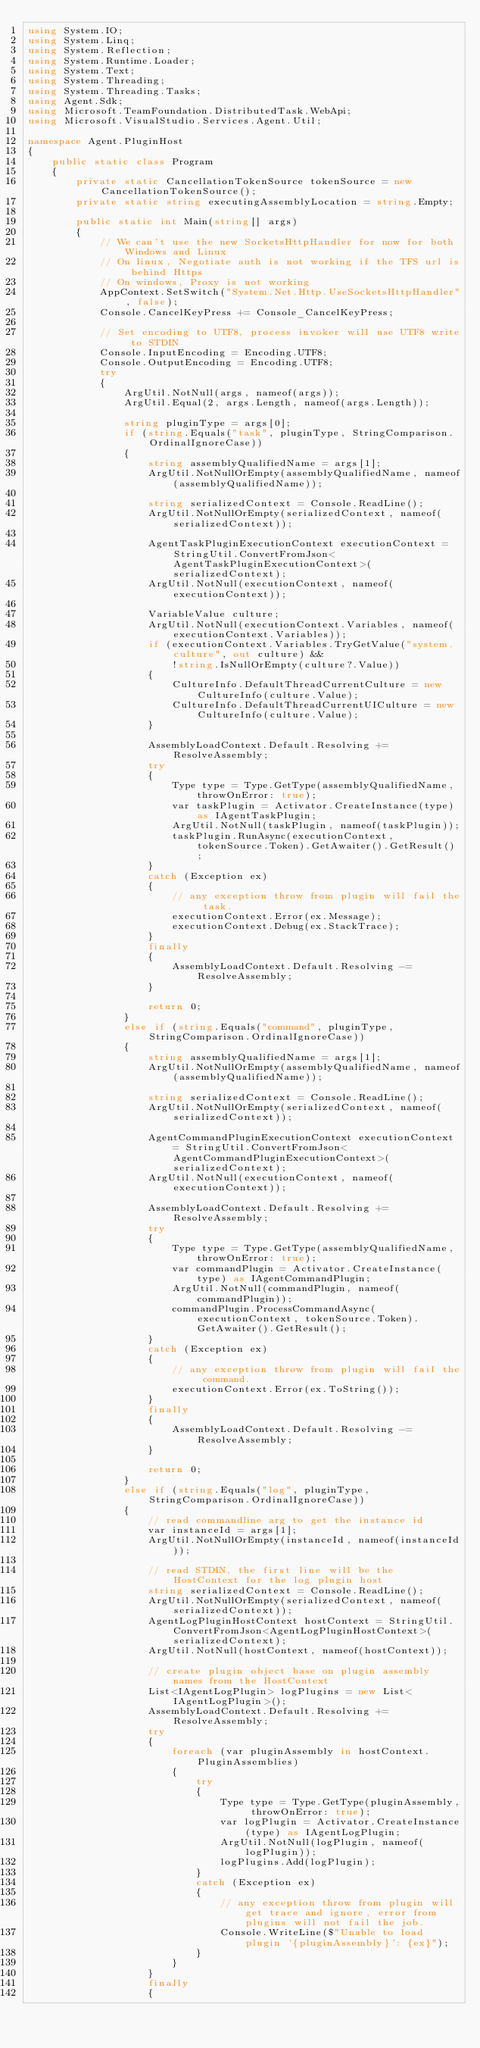<code> <loc_0><loc_0><loc_500><loc_500><_C#_>using System.IO;
using System.Linq;
using System.Reflection;
using System.Runtime.Loader;
using System.Text;
using System.Threading;
using System.Threading.Tasks;
using Agent.Sdk;
using Microsoft.TeamFoundation.DistributedTask.WebApi;
using Microsoft.VisualStudio.Services.Agent.Util;

namespace Agent.PluginHost
{
    public static class Program
    {
        private static CancellationTokenSource tokenSource = new CancellationTokenSource();
        private static string executingAssemblyLocation = string.Empty;

        public static int Main(string[] args)
        {
            // We can't use the new SocketsHttpHandler for now for both Windows and Linux
            // On linux, Negotiate auth is not working if the TFS url is behind Https
            // On windows, Proxy is not working
            AppContext.SetSwitch("System.Net.Http.UseSocketsHttpHandler", false);
            Console.CancelKeyPress += Console_CancelKeyPress;

            // Set encoding to UTF8, process invoker will use UTF8 write to STDIN
            Console.InputEncoding = Encoding.UTF8;
            Console.OutputEncoding = Encoding.UTF8;
            try
            {
                ArgUtil.NotNull(args, nameof(args));
                ArgUtil.Equal(2, args.Length, nameof(args.Length));

                string pluginType = args[0];
                if (string.Equals("task", pluginType, StringComparison.OrdinalIgnoreCase))
                {
                    string assemblyQualifiedName = args[1];
                    ArgUtil.NotNullOrEmpty(assemblyQualifiedName, nameof(assemblyQualifiedName));

                    string serializedContext = Console.ReadLine();
                    ArgUtil.NotNullOrEmpty(serializedContext, nameof(serializedContext));

                    AgentTaskPluginExecutionContext executionContext = StringUtil.ConvertFromJson<AgentTaskPluginExecutionContext>(serializedContext);
                    ArgUtil.NotNull(executionContext, nameof(executionContext));

                    VariableValue culture;
                    ArgUtil.NotNull(executionContext.Variables, nameof(executionContext.Variables));
                    if (executionContext.Variables.TryGetValue("system.culture", out culture) &&
                        !string.IsNullOrEmpty(culture?.Value))
                    {
                        CultureInfo.DefaultThreadCurrentCulture = new CultureInfo(culture.Value);
                        CultureInfo.DefaultThreadCurrentUICulture = new CultureInfo(culture.Value);
                    }

                    AssemblyLoadContext.Default.Resolving += ResolveAssembly;
                    try
                    {
                        Type type = Type.GetType(assemblyQualifiedName, throwOnError: true);
                        var taskPlugin = Activator.CreateInstance(type) as IAgentTaskPlugin;
                        ArgUtil.NotNull(taskPlugin, nameof(taskPlugin));
                        taskPlugin.RunAsync(executionContext, tokenSource.Token).GetAwaiter().GetResult();
                    }
                    catch (Exception ex)
                    {
                        // any exception throw from plugin will fail the task.
                        executionContext.Error(ex.Message);
                        executionContext.Debug(ex.StackTrace);
                    }
                    finally
                    {
                        AssemblyLoadContext.Default.Resolving -= ResolveAssembly;
                    }

                    return 0;
                }
                else if (string.Equals("command", pluginType, StringComparison.OrdinalIgnoreCase))
                {
                    string assemblyQualifiedName = args[1];
                    ArgUtil.NotNullOrEmpty(assemblyQualifiedName, nameof(assemblyQualifiedName));

                    string serializedContext = Console.ReadLine();
                    ArgUtil.NotNullOrEmpty(serializedContext, nameof(serializedContext));

                    AgentCommandPluginExecutionContext executionContext = StringUtil.ConvertFromJson<AgentCommandPluginExecutionContext>(serializedContext);
                    ArgUtil.NotNull(executionContext, nameof(executionContext));

                    AssemblyLoadContext.Default.Resolving += ResolveAssembly;
                    try
                    {
                        Type type = Type.GetType(assemblyQualifiedName, throwOnError: true);
                        var commandPlugin = Activator.CreateInstance(type) as IAgentCommandPlugin;
                        ArgUtil.NotNull(commandPlugin, nameof(commandPlugin));
                        commandPlugin.ProcessCommandAsync(executionContext, tokenSource.Token).GetAwaiter().GetResult();
                    }
                    catch (Exception ex)
                    {
                        // any exception throw from plugin will fail the command.
                        executionContext.Error(ex.ToString());
                    }
                    finally
                    {
                        AssemblyLoadContext.Default.Resolving -= ResolveAssembly;
                    }

                    return 0;
                }
                else if (string.Equals("log", pluginType, StringComparison.OrdinalIgnoreCase))
                {
                    // read commandline arg to get the instance id
                    var instanceId = args[1];
                    ArgUtil.NotNullOrEmpty(instanceId, nameof(instanceId));

                    // read STDIN, the first line will be the HostContext for the log plugin host
                    string serializedContext = Console.ReadLine();
                    ArgUtil.NotNullOrEmpty(serializedContext, nameof(serializedContext));
                    AgentLogPluginHostContext hostContext = StringUtil.ConvertFromJson<AgentLogPluginHostContext>(serializedContext);
                    ArgUtil.NotNull(hostContext, nameof(hostContext));

                    // create plugin object base on plugin assembly names from the HostContext
                    List<IAgentLogPlugin> logPlugins = new List<IAgentLogPlugin>();
                    AssemblyLoadContext.Default.Resolving += ResolveAssembly;
                    try
                    {
                        foreach (var pluginAssembly in hostContext.PluginAssemblies)
                        {
                            try
                            {
                                Type type = Type.GetType(pluginAssembly, throwOnError: true);
                                var logPlugin = Activator.CreateInstance(type) as IAgentLogPlugin;
                                ArgUtil.NotNull(logPlugin, nameof(logPlugin));
                                logPlugins.Add(logPlugin);
                            }
                            catch (Exception ex)
                            {
                                // any exception throw from plugin will get trace and ignore, error from plugins will not fail the job.
                                Console.WriteLine($"Unable to load plugin '{pluginAssembly}': {ex}");
                            }
                        }
                    }
                    finally
                    {</code> 